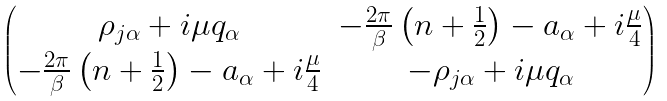Convert formula to latex. <formula><loc_0><loc_0><loc_500><loc_500>\begin{pmatrix} \rho _ { j \alpha } + i \mu q _ { \alpha } & - \frac { 2 \pi } { \beta } \left ( n + \frac { 1 } { 2 } \right ) - a _ { \alpha } + i \frac { \mu } { 4 } \\ - \frac { 2 \pi } { \beta } \left ( n + \frac { 1 } { 2 } \right ) - a _ { \alpha } + i \frac { \mu } { 4 } & - \rho _ { j \alpha } + i \mu q _ { \alpha } \end{pmatrix}</formula> 